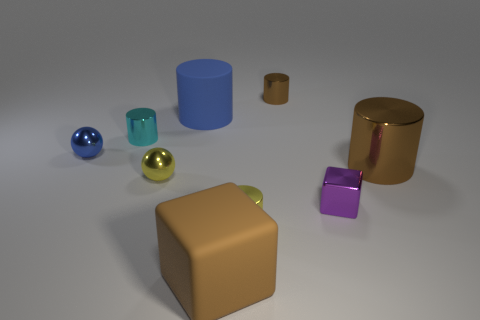Subtract all big metallic cylinders. How many cylinders are left? 4 Subtract all yellow cylinders. How many cylinders are left? 4 Subtract all cubes. How many objects are left? 7 Subtract all blue balls. How many brown cylinders are left? 2 Subtract 5 cylinders. How many cylinders are left? 0 Subtract all brown blocks. Subtract all cyan cylinders. How many blocks are left? 1 Subtract all small red cylinders. Subtract all brown rubber cubes. How many objects are left? 8 Add 6 small brown cylinders. How many small brown cylinders are left? 7 Add 2 big objects. How many big objects exist? 5 Subtract 0 purple cylinders. How many objects are left? 9 